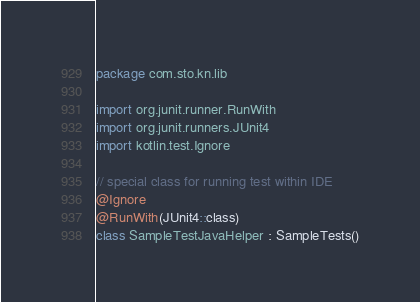Convert code to text. <code><loc_0><loc_0><loc_500><loc_500><_Kotlin_>package com.sto.kn.lib

import org.junit.runner.RunWith
import org.junit.runners.JUnit4
import kotlin.test.Ignore

// special class for running test within IDE
@Ignore
@RunWith(JUnit4::class)
class SampleTestJavaHelper : SampleTests()
</code> 